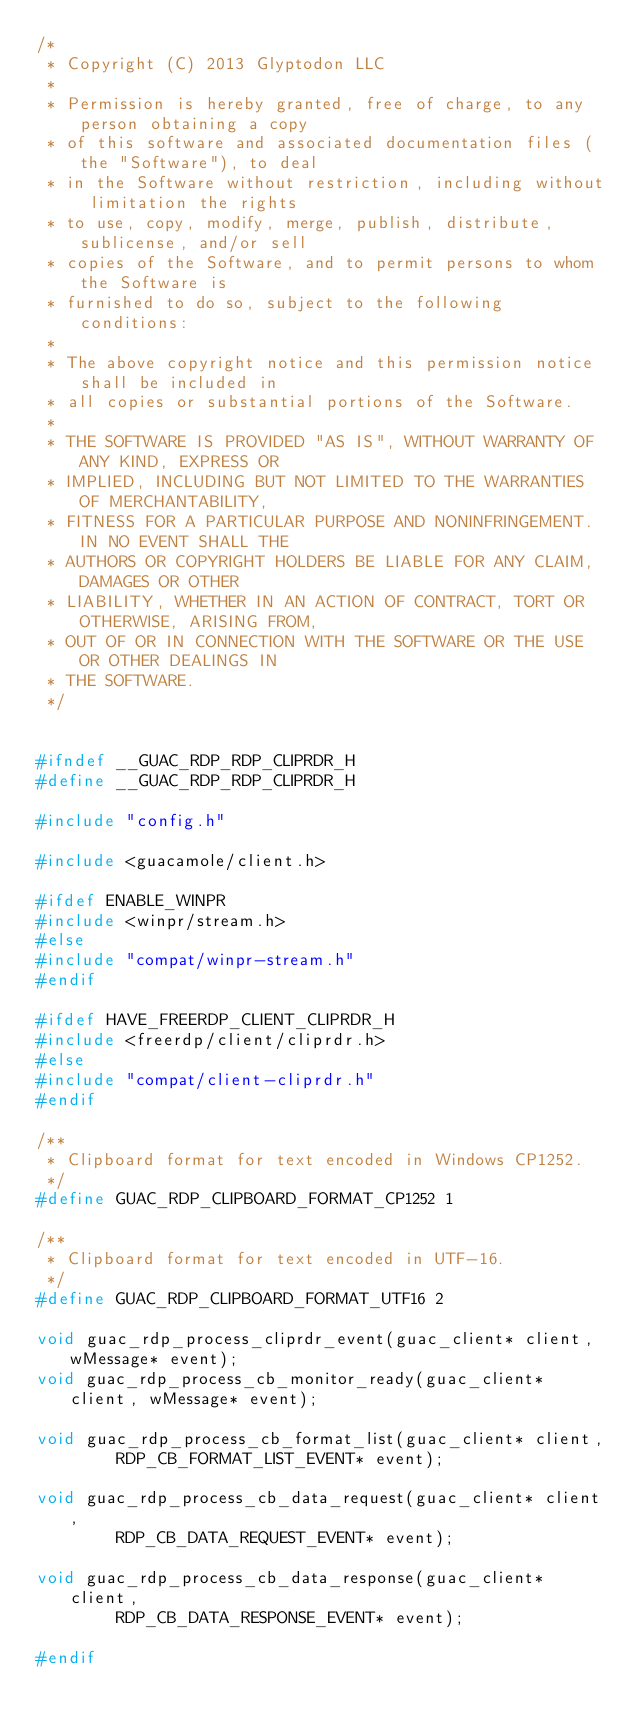<code> <loc_0><loc_0><loc_500><loc_500><_C_>/*
 * Copyright (C) 2013 Glyptodon LLC
 *
 * Permission is hereby granted, free of charge, to any person obtaining a copy
 * of this software and associated documentation files (the "Software"), to deal
 * in the Software without restriction, including without limitation the rights
 * to use, copy, modify, merge, publish, distribute, sublicense, and/or sell
 * copies of the Software, and to permit persons to whom the Software is
 * furnished to do so, subject to the following conditions:
 *
 * The above copyright notice and this permission notice shall be included in
 * all copies or substantial portions of the Software.
 *
 * THE SOFTWARE IS PROVIDED "AS IS", WITHOUT WARRANTY OF ANY KIND, EXPRESS OR
 * IMPLIED, INCLUDING BUT NOT LIMITED TO THE WARRANTIES OF MERCHANTABILITY,
 * FITNESS FOR A PARTICULAR PURPOSE AND NONINFRINGEMENT. IN NO EVENT SHALL THE
 * AUTHORS OR COPYRIGHT HOLDERS BE LIABLE FOR ANY CLAIM, DAMAGES OR OTHER
 * LIABILITY, WHETHER IN AN ACTION OF CONTRACT, TORT OR OTHERWISE, ARISING FROM,
 * OUT OF OR IN CONNECTION WITH THE SOFTWARE OR THE USE OR OTHER DEALINGS IN
 * THE SOFTWARE.
 */


#ifndef __GUAC_RDP_RDP_CLIPRDR_H
#define __GUAC_RDP_RDP_CLIPRDR_H

#include "config.h"

#include <guacamole/client.h>

#ifdef ENABLE_WINPR
#include <winpr/stream.h>
#else
#include "compat/winpr-stream.h"
#endif

#ifdef HAVE_FREERDP_CLIENT_CLIPRDR_H
#include <freerdp/client/cliprdr.h>
#else
#include "compat/client-cliprdr.h"
#endif

/**
 * Clipboard format for text encoded in Windows CP1252.
 */
#define GUAC_RDP_CLIPBOARD_FORMAT_CP1252 1

/**
 * Clipboard format for text encoded in UTF-16.
 */
#define GUAC_RDP_CLIPBOARD_FORMAT_UTF16 2

void guac_rdp_process_cliprdr_event(guac_client* client, wMessage* event);
void guac_rdp_process_cb_monitor_ready(guac_client* client, wMessage* event);

void guac_rdp_process_cb_format_list(guac_client* client,
        RDP_CB_FORMAT_LIST_EVENT* event);

void guac_rdp_process_cb_data_request(guac_client* client,
        RDP_CB_DATA_REQUEST_EVENT* event);

void guac_rdp_process_cb_data_response(guac_client* client,
        RDP_CB_DATA_RESPONSE_EVENT* event);

#endif

</code> 